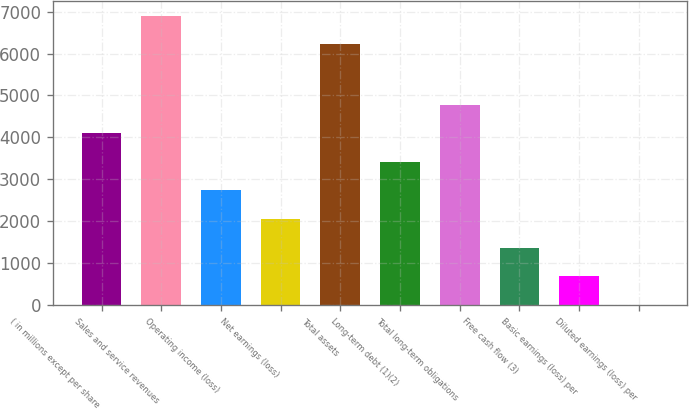Convert chart to OTSL. <chart><loc_0><loc_0><loc_500><loc_500><bar_chart><fcel>( in millions except per share<fcel>Sales and service revenues<fcel>Operating income (loss)<fcel>Net earnings (loss)<fcel>Total assets<fcel>Long-term debt (1)(2)<fcel>Total long-term obligations<fcel>Free cash flow (3)<fcel>Basic earnings (loss) per<fcel>Diluted earnings (loss) per<nl><fcel>4094.06<fcel>6906.48<fcel>2731.1<fcel>2049.62<fcel>6225<fcel>3412.58<fcel>4775.54<fcel>1368.14<fcel>686.66<fcel>5.18<nl></chart> 